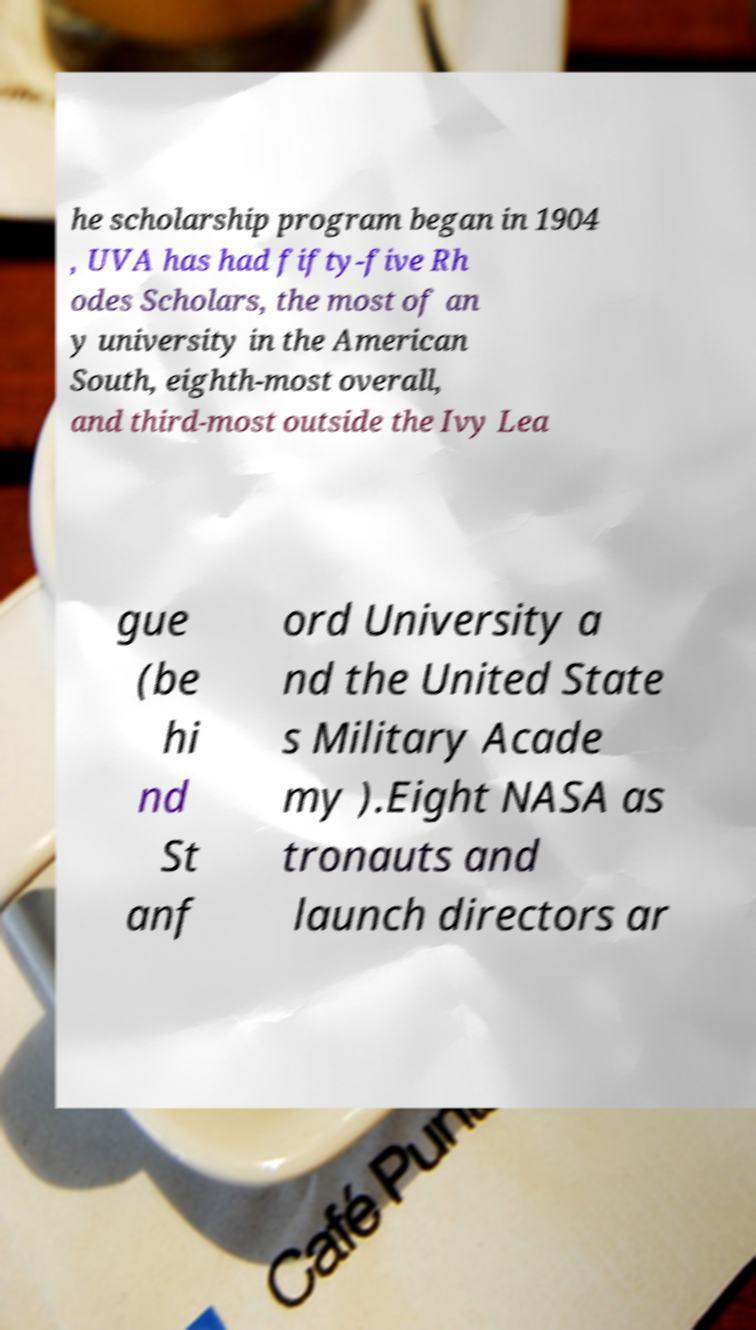Please identify and transcribe the text found in this image. he scholarship program began in 1904 , UVA has had fifty-five Rh odes Scholars, the most of an y university in the American South, eighth-most overall, and third-most outside the Ivy Lea gue (be hi nd St anf ord University a nd the United State s Military Acade my ).Eight NASA as tronauts and launch directors ar 